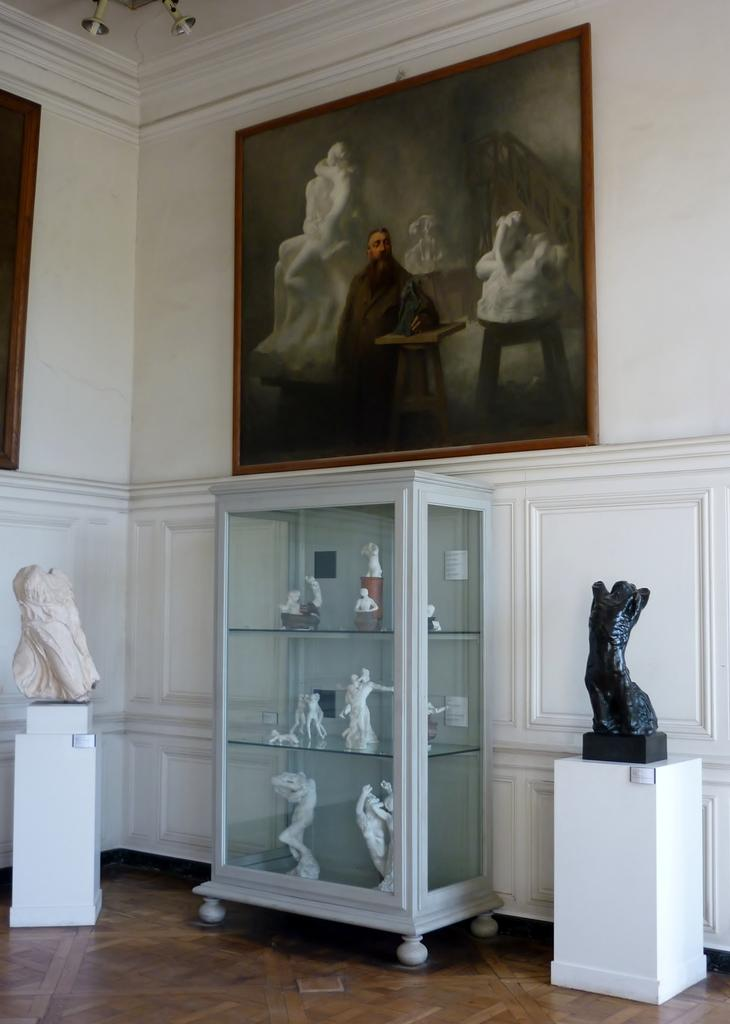What type of art is present in the image? There are sculptures in the image. What can be seen on the wall in the image? There are photos on the wall in the image. What is on the floor in the image? There are objects on the floor in the image. What type of furniture is present in the image? There is a glass cupboard in the image. What is inside the glass cupboard? The glass cupboard contains objects. What is the profit margin of the organization depicted in the image? There is no organization or profit margin mentioned in the image; it features sculptures, photos, objects, and a glass cupboard. How does the health of the individuals in the image compare to the national average? There are no individuals present in the image, so it is impossible to compare their health to the national average. 